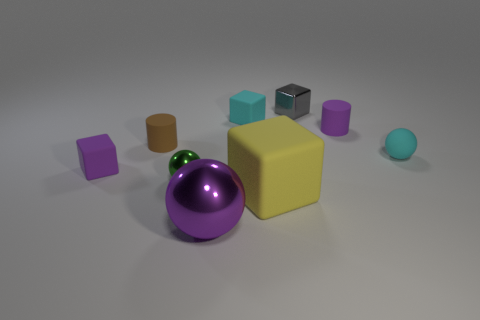Subtract all tiny spheres. How many spheres are left? 1 Add 1 small green spheres. How many objects exist? 10 Subtract all balls. How many objects are left? 6 Subtract 2 cylinders. How many cylinders are left? 0 Subtract all purple balls. How many balls are left? 2 Add 8 tiny purple matte objects. How many tiny purple matte objects exist? 10 Subtract 0 green cylinders. How many objects are left? 9 Subtract all brown balls. Subtract all cyan cylinders. How many balls are left? 3 Subtract all blue shiny cylinders. Subtract all purple shiny objects. How many objects are left? 8 Add 1 large spheres. How many large spheres are left? 2 